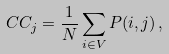Convert formula to latex. <formula><loc_0><loc_0><loc_500><loc_500>C C _ { j } = \frac { 1 } { N } \sum _ { i \in V } P ( i , j ) \, ,</formula> 